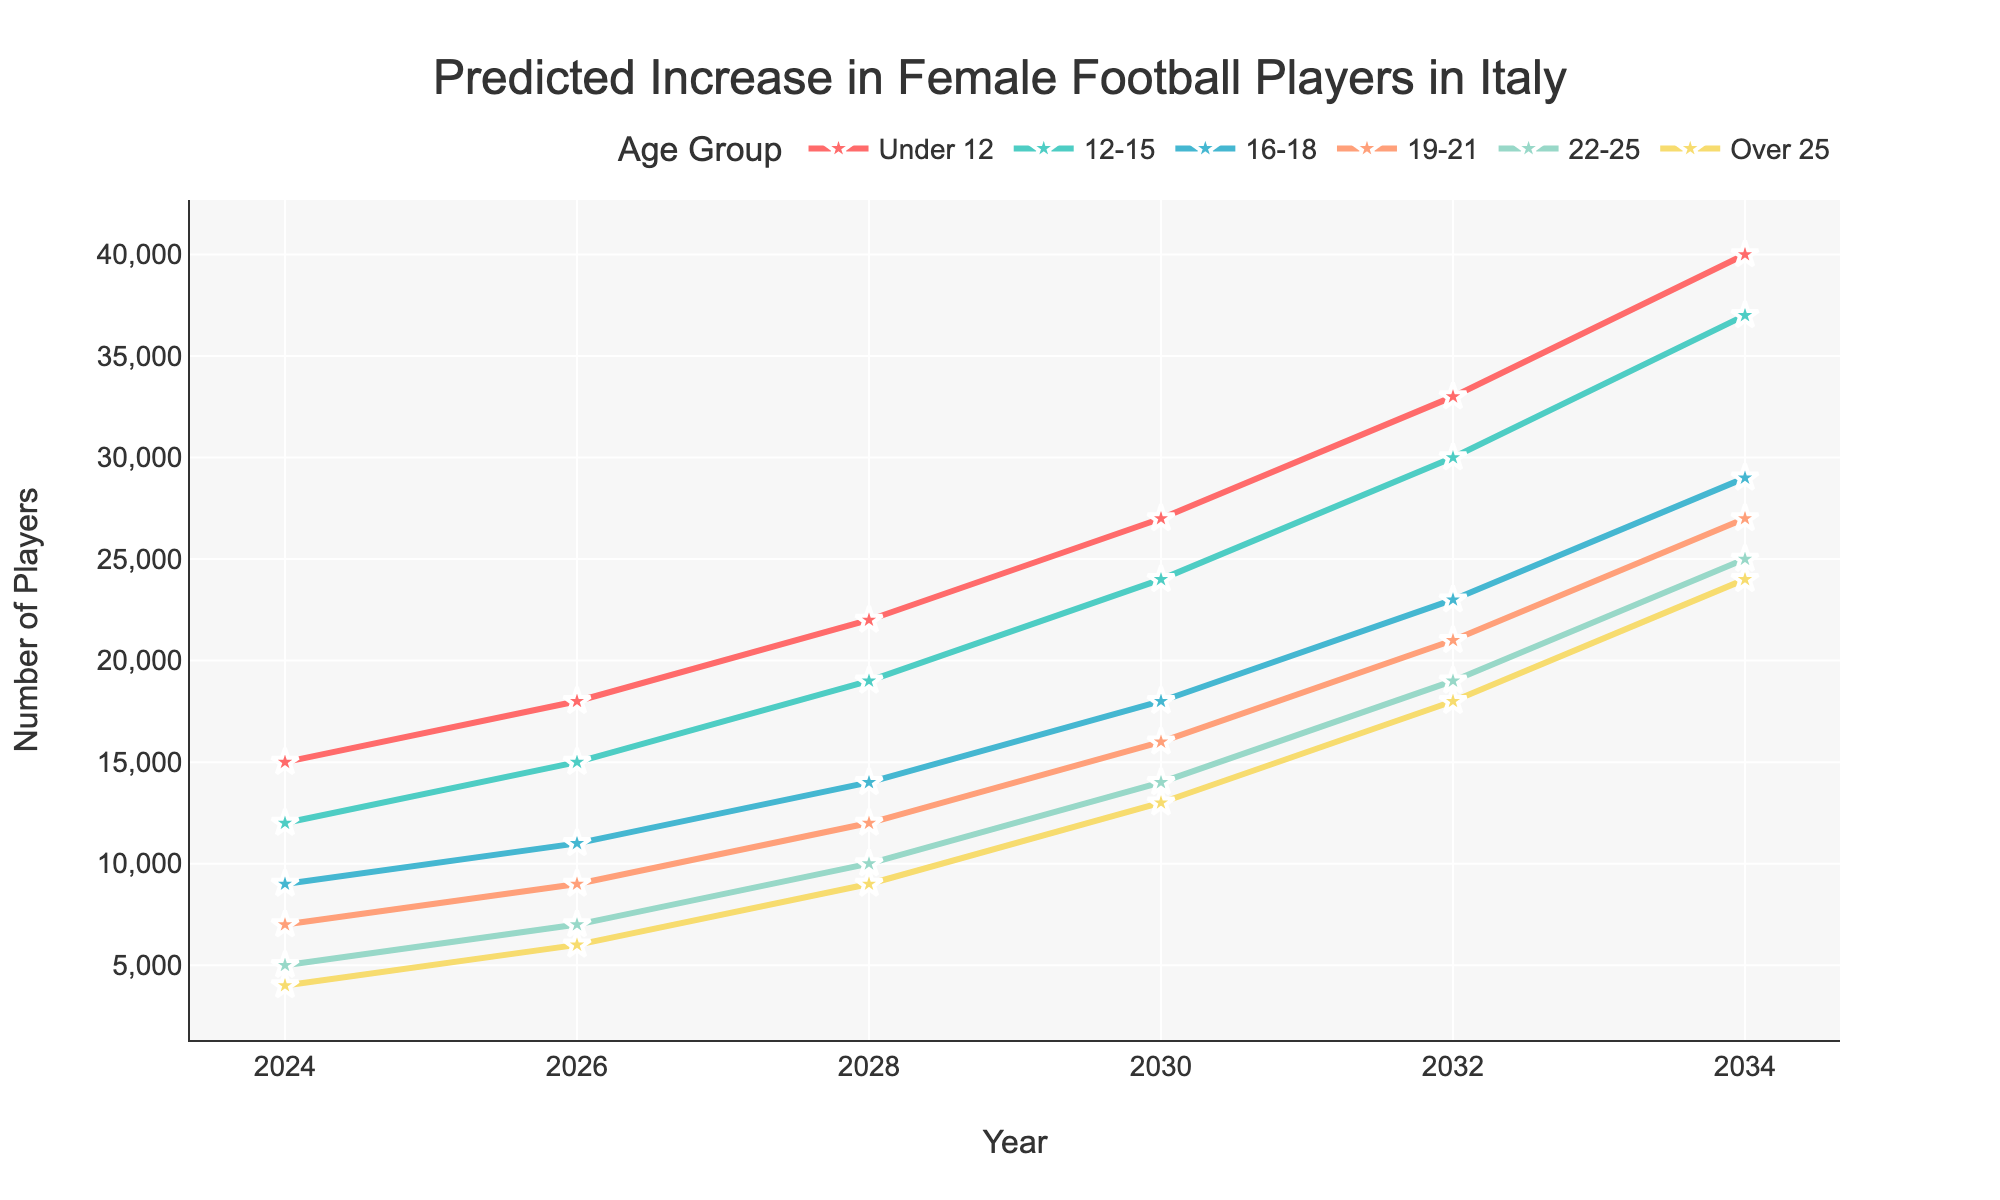What is the title of the plot? The plot title is located at the top center and it usually provides a summary of the content displayed in the plot. In this case, the title is "Predicted Increase in Female Football Players in Italy".
Answer: Predicted Increase in Female Football Players in Italy How many age groups are represented in the plot? The plot legend displays the different categories or groups represented in the plot. By checking the legend, it is clear that there are six age groups represented.
Answer: Six Which age group has the highest predicted number of players in 2034? To identify this, look at the data points corresponding to the year 2034 across all age groups. The age group with the highest value is "Under 12" with 40,000 players.
Answer: Under 12 What is the predicted number of players in the 22-25 age group in 2026? To find this, focus on the line corresponding to the "22-25" age group and locate the data point for the year 2026. The predicted number of players in this age group is 7,000.
Answer: 7,000 By how much is the number of players in the 16-18 age group predicted to increase from 2024 to 2030? To determine the increase, find the values for the years 2024 and 2030 for the "16-18" age group and calculate the difference. The values are 9,000 for 2024 and 18,000 for 2030, which gives an increase of 9,000 players.
Answer: 9,000 Which two age groups have the closest predicted number of players in 2028? Compare the predicted numbers for each age group in the year 2028 to find those with the closest values. The age groups "12-15" and "16-18" have 19,000 and 14,000 players respectively, making their difference the smallest.
Answer: 12-15 and 16-18 Is the number of players in the over 25 age group predicted to surpass the 19-21 age group by 2034? By analyzing the predicted numbers for the year 2034, compare the "over 25" age group with 24,000 players and the "19-21" age group with 27,000 players. The "over 25" age group does not surpass the "19-21" age group.
Answer: No What is the total predicted number of players across all age groups in 2032? Sum the predicted numbers for all age groups in the year 2032. The totals are 33,000 (Under 12) + 30,000 (12-15) + 23,000 (16-18) + 21,000 (19-21) + 19,000 (22-25) + 18,000 (Over 25) = 144,000.
Answer: 144,000 What trend can be observed for the number of players in each age group from 2024 to 2034? Observing the lines for each age group from 2024 to 2034, it is clear that all lines show an upward trend indicating an increase in the number of players for all age groups over the decade.
Answer: Upward trend Which age group shows the most significant increase in players from 2024 to 2034? To determine the most significant increase, look at the end points of each line at 2024 and 2034. The "Under 12" age group increases from 15,000 to 40,000, which is the largest increase of 25,000 players.
Answer: Under 12 